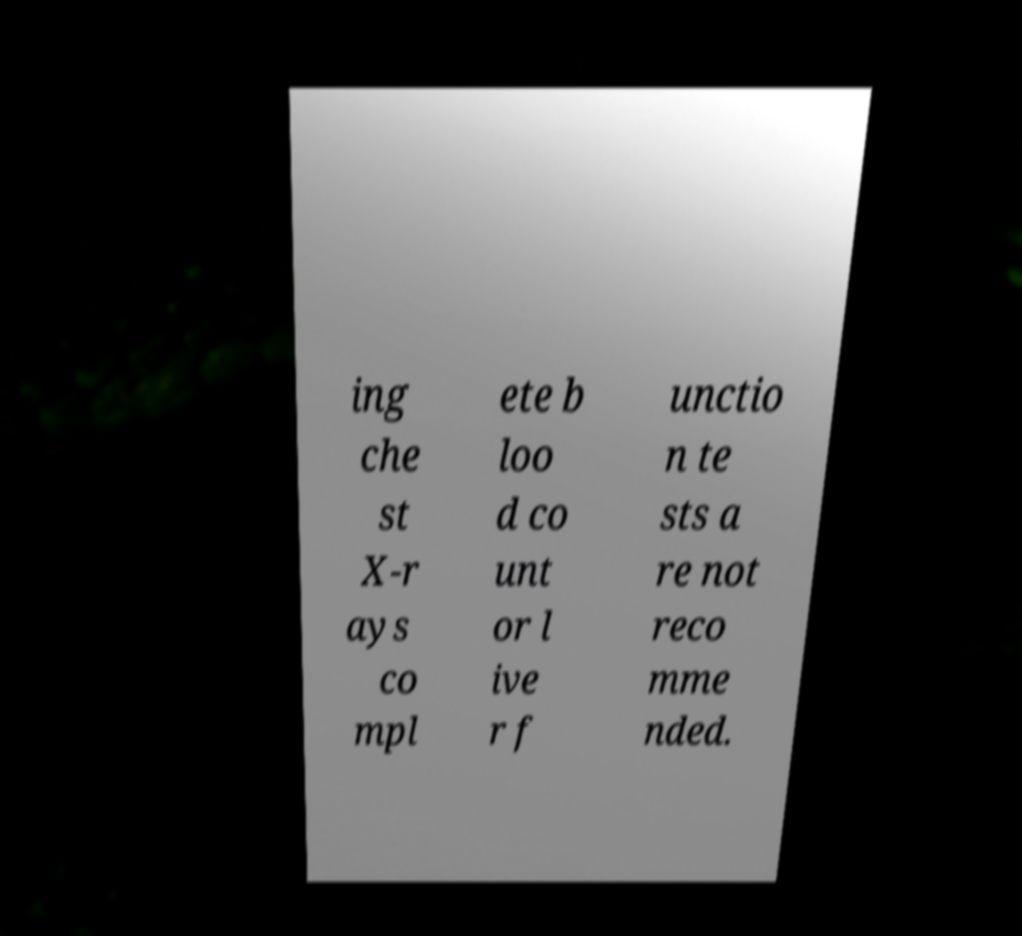Could you assist in decoding the text presented in this image and type it out clearly? ing che st X-r ays co mpl ete b loo d co unt or l ive r f unctio n te sts a re not reco mme nded. 